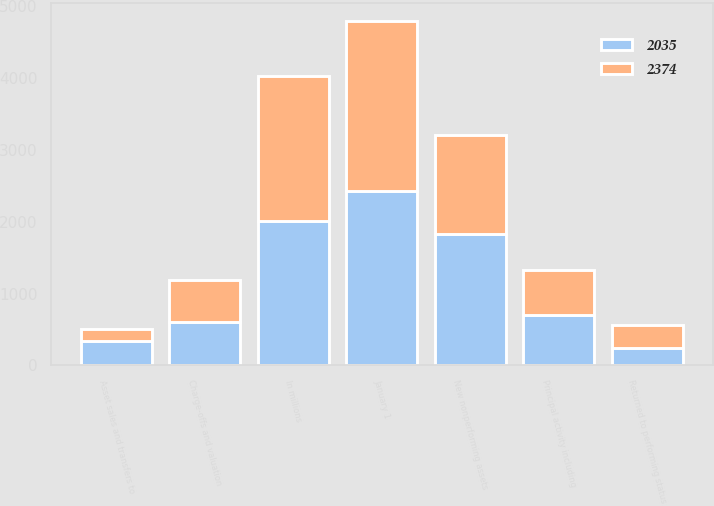Convert chart. <chart><loc_0><loc_0><loc_500><loc_500><stacked_bar_chart><ecel><fcel>In millions<fcel>January 1<fcel>New nonperforming assets<fcel>Charge-offs and valuation<fcel>Principal activity including<fcel>Asset sales and transfers to<fcel>Returned to performing status<nl><fcel>2374<fcel>2017<fcel>2374<fcel>1376<fcel>585<fcel>638<fcel>178<fcel>314<nl><fcel>2035<fcel>2016<fcel>2425<fcel>1835<fcel>604<fcel>697<fcel>336<fcel>249<nl></chart> 